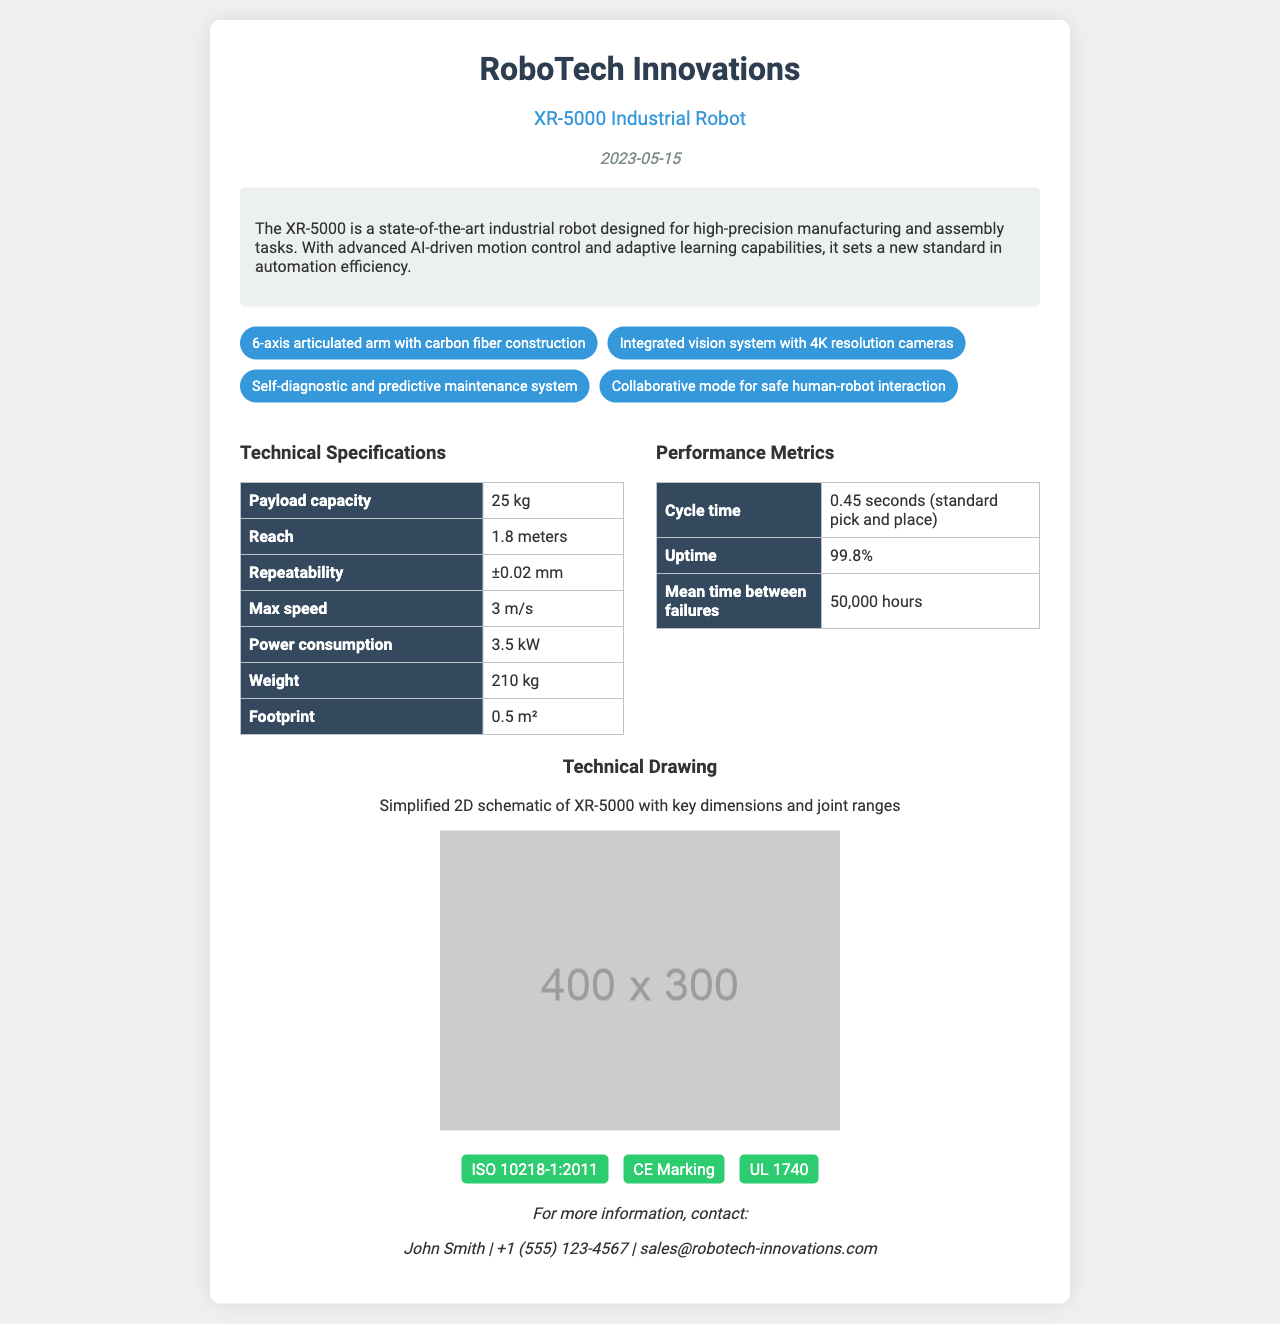what is the model number of the robot? The model number is listed at the top of the document under the product name.
Answer: XR-5000 what is the payload capacity of the XR-5000? The payload capacity is specified in the technical specifications table.
Answer: 25 kg when was the specification sheet dated? The date is provided in the header section of the document.
Answer: 2023-05-15 what is the mean time between failures for the XR-5000? The value is found in the performance metrics table.
Answer: 50,000 hours how many key features are listed for the XR-5000? The number of key features can be counted from the key features section.
Answer: 4 what is the cycle time for standard pick and place? The cycle time is mentioned in the performance metrics table.
Answer: 0.45 seconds what type of arm does the XR-5000 have? The arm type is described in the key features section.
Answer: 6-axis articulated arm which certification indicates compliance with safety standards for industrial robots? Compliance certifications are listed at the bottom of the document.
Answer: ISO 10218-1:2011 who is the contact person for more information? The contact person's name is provided in the contact section of the document.
Answer: John Smith 